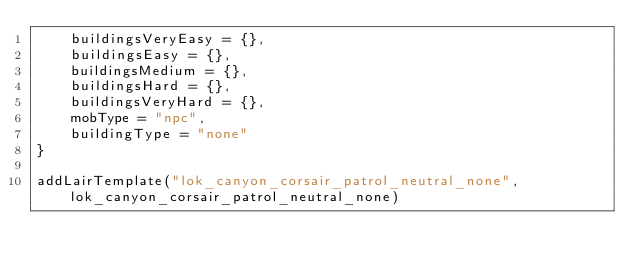<code> <loc_0><loc_0><loc_500><loc_500><_Lua_>	buildingsVeryEasy = {},
	buildingsEasy = {},
	buildingsMedium = {},
	buildingsHard = {},
	buildingsVeryHard = {},
	mobType = "npc",
	buildingType = "none"
}

addLairTemplate("lok_canyon_corsair_patrol_neutral_none", lok_canyon_corsair_patrol_neutral_none)
</code> 